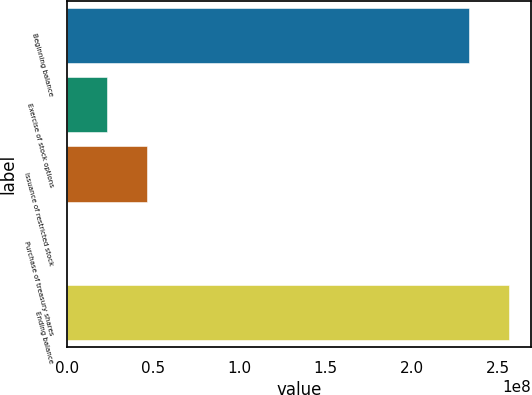<chart> <loc_0><loc_0><loc_500><loc_500><bar_chart><fcel>Beginning balance<fcel>Exercise of stock options<fcel>Issuance of restricted stock<fcel>Purchase of treasury shares<fcel>Ending balance<nl><fcel>2.33114e+08<fcel>2.33394e+07<fcel>4.66669e+07<fcel>11851<fcel>2.56442e+08<nl></chart> 